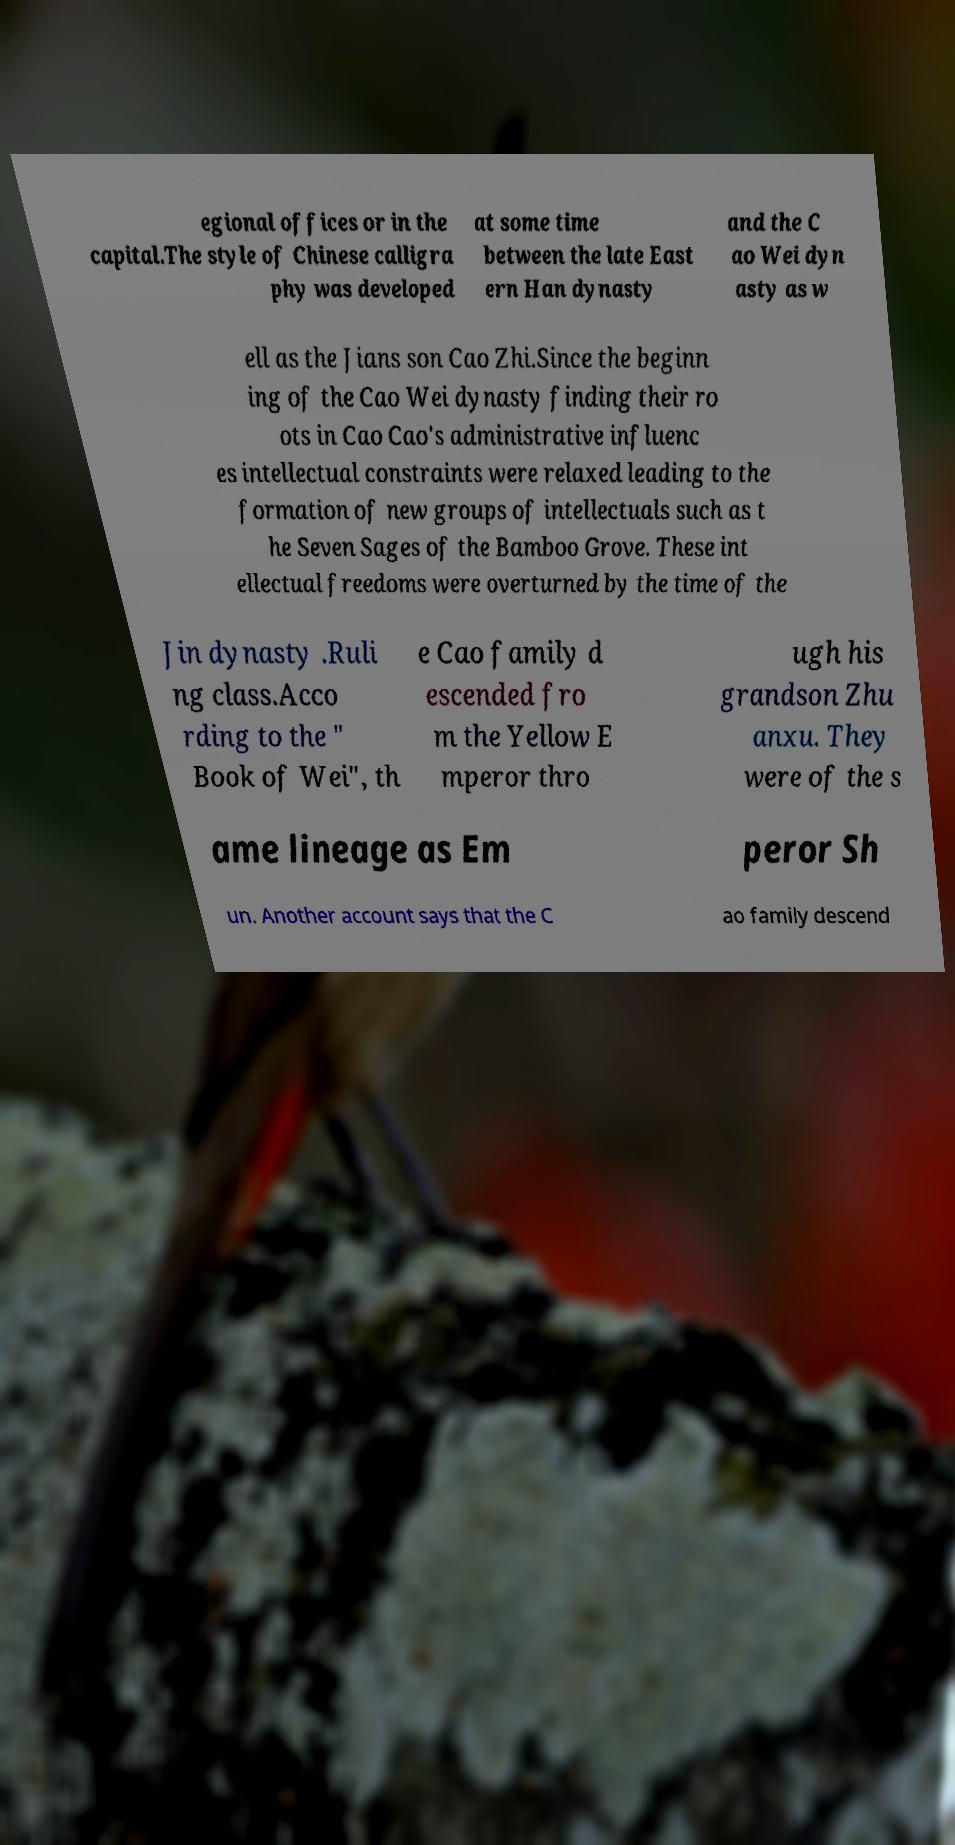Please read and relay the text visible in this image. What does it say? egional offices or in the capital.The style of Chinese calligra phy was developed at some time between the late East ern Han dynasty and the C ao Wei dyn asty as w ell as the Jians son Cao Zhi.Since the beginn ing of the Cao Wei dynasty finding their ro ots in Cao Cao's administrative influenc es intellectual constraints were relaxed leading to the formation of new groups of intellectuals such as t he Seven Sages of the Bamboo Grove. These int ellectual freedoms were overturned by the time of the Jin dynasty .Ruli ng class.Acco rding to the " Book of Wei", th e Cao family d escended fro m the Yellow E mperor thro ugh his grandson Zhu anxu. They were of the s ame lineage as Em peror Sh un. Another account says that the C ao family descend 